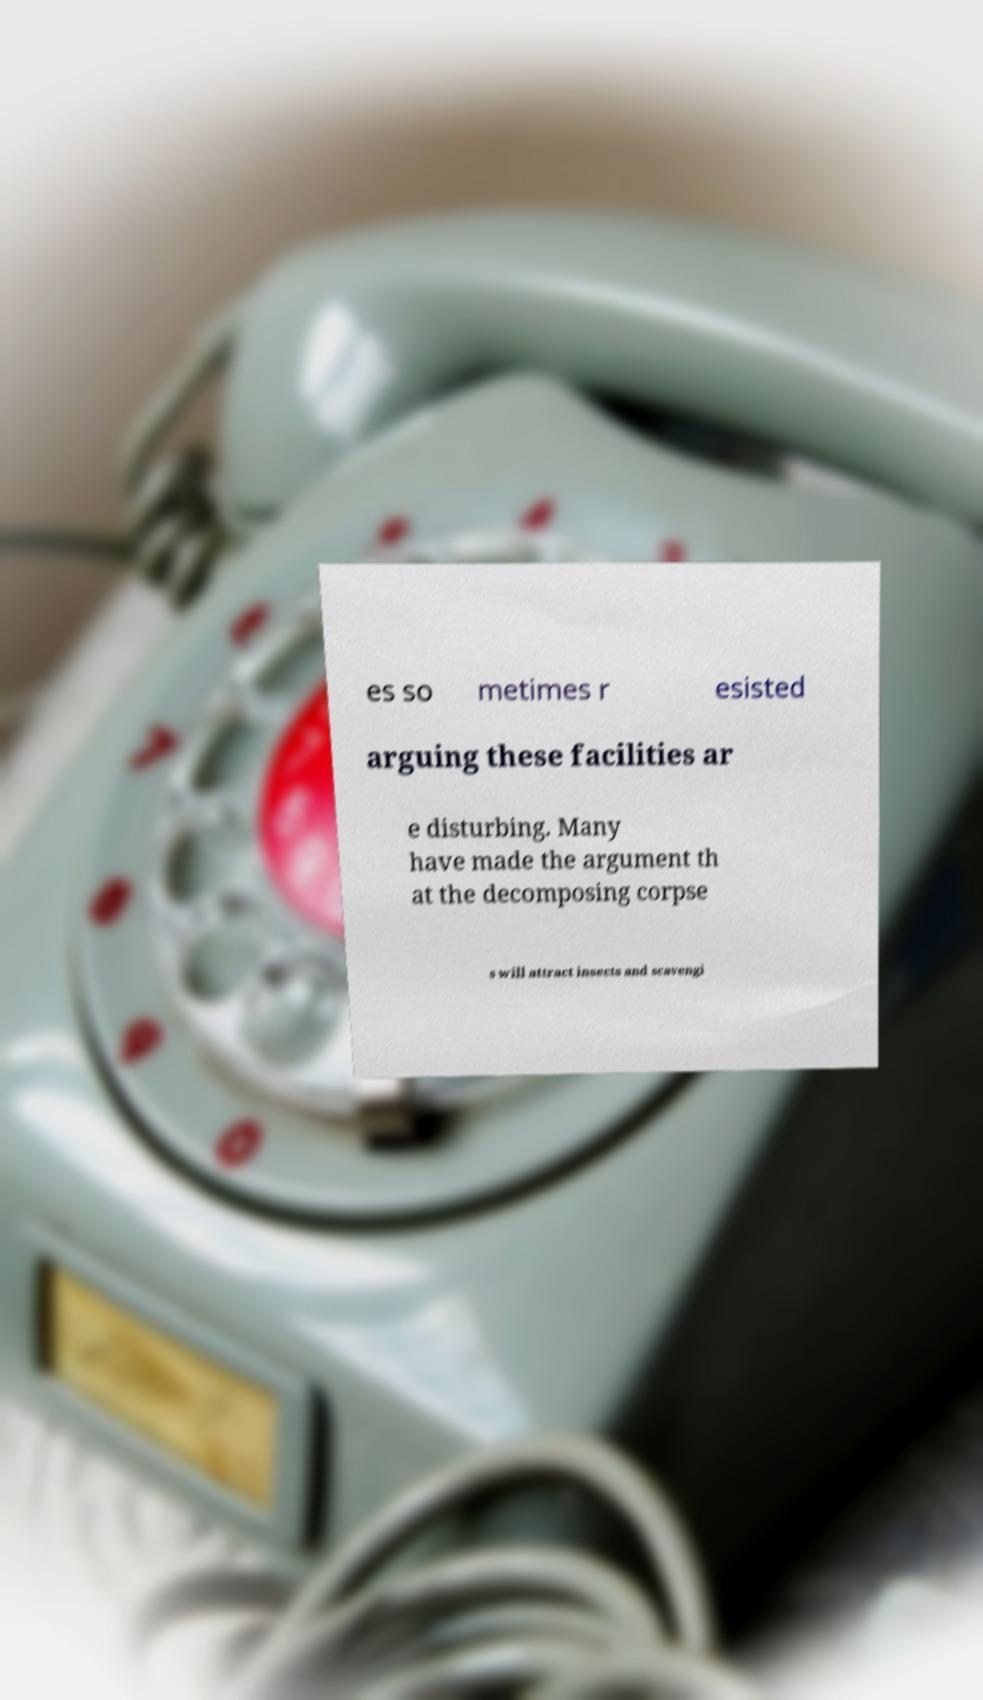I need the written content from this picture converted into text. Can you do that? es so metimes r esisted arguing these facilities ar e disturbing. Many have made the argument th at the decomposing corpse s will attract insects and scavengi 